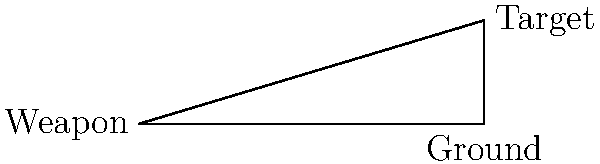In a long-range mission scenario, an operative needs to determine the angle of fire for their weapon. The target is located 1000 meters away horizontally and 300 meters above the operative's position. What is the angle of elevation (θ) required for the weapon to hit the target? (Assume ideal conditions and ignore factors like wind or bullet drop.) To solve this problem, we'll use basic trigonometry:

1. We have a right triangle where:
   - The adjacent side (ground distance) is 1000 meters
   - The opposite side (height difference) is 300 meters
   - We need to find the angle θ

2. The tangent of an angle in a right triangle is the ratio of the opposite side to the adjacent side:

   $$\tan(\theta) = \frac{\text{opposite}}{\text{adjacent}} = \frac{\text{height}}{\text{distance}}$$

3. Plugging in our values:

   $$\tan(\theta) = \frac{300}{1000} = 0.3$$

4. To find θ, we need to use the inverse tangent (arctan or tan^(-1)):

   $$\theta = \tan^{-1}(0.3)$$

5. Using a calculator or trigonometric tables:

   $$\theta \approx 16.70^\circ$$

6. Round to two decimal places:

   $$\theta \approx 16.70^\circ$$

Therefore, the operative needs to aim at an angle of approximately 16.70° above the horizontal to hit the target.
Answer: 16.70° 